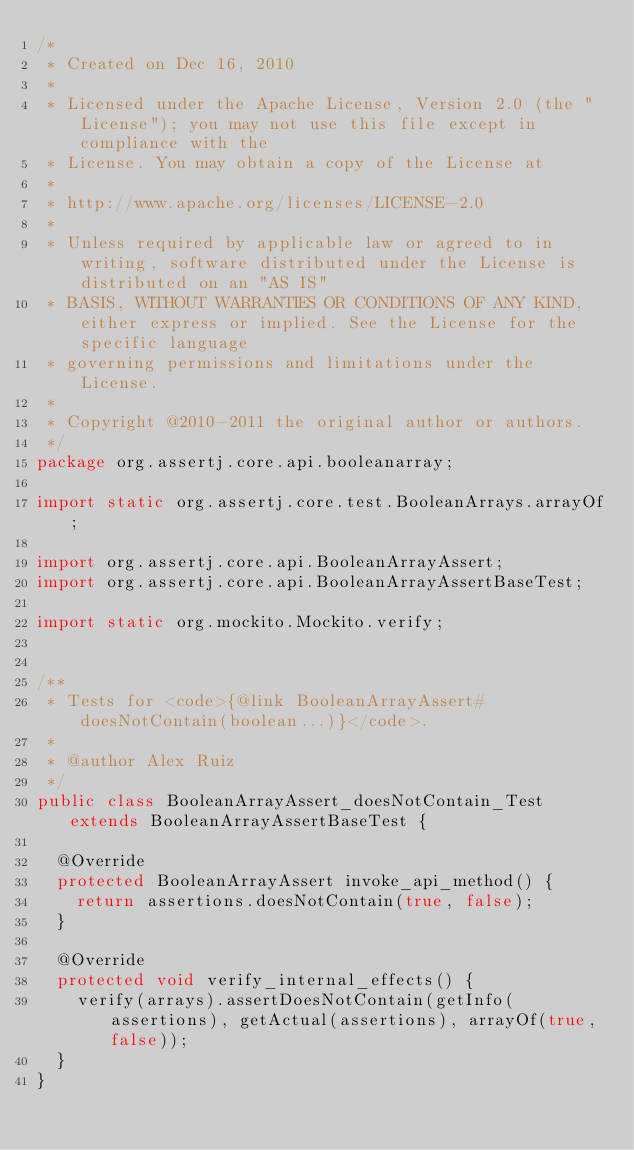Convert code to text. <code><loc_0><loc_0><loc_500><loc_500><_Java_>/*
 * Created on Dec 16, 2010
 * 
 * Licensed under the Apache License, Version 2.0 (the "License"); you may not use this file except in compliance with the
 * License. You may obtain a copy of the License at
 * 
 * http://www.apache.org/licenses/LICENSE-2.0
 * 
 * Unless required by applicable law or agreed to in writing, software distributed under the License is distributed on an "AS IS"
 * BASIS, WITHOUT WARRANTIES OR CONDITIONS OF ANY KIND, either express or implied. See the License for the specific language
 * governing permissions and limitations under the License.
 * 
 * Copyright @2010-2011 the original author or authors.
 */
package org.assertj.core.api.booleanarray;

import static org.assertj.core.test.BooleanArrays.arrayOf;

import org.assertj.core.api.BooleanArrayAssert;
import org.assertj.core.api.BooleanArrayAssertBaseTest;

import static org.mockito.Mockito.verify;


/**
 * Tests for <code>{@link BooleanArrayAssert#doesNotContain(boolean...)}</code>.
 * 
 * @author Alex Ruiz
 */
public class BooleanArrayAssert_doesNotContain_Test extends BooleanArrayAssertBaseTest {

  @Override
  protected BooleanArrayAssert invoke_api_method() {
    return assertions.doesNotContain(true, false);
  }

  @Override
  protected void verify_internal_effects() {
    verify(arrays).assertDoesNotContain(getInfo(assertions), getActual(assertions), arrayOf(true, false));
  }
}
</code> 